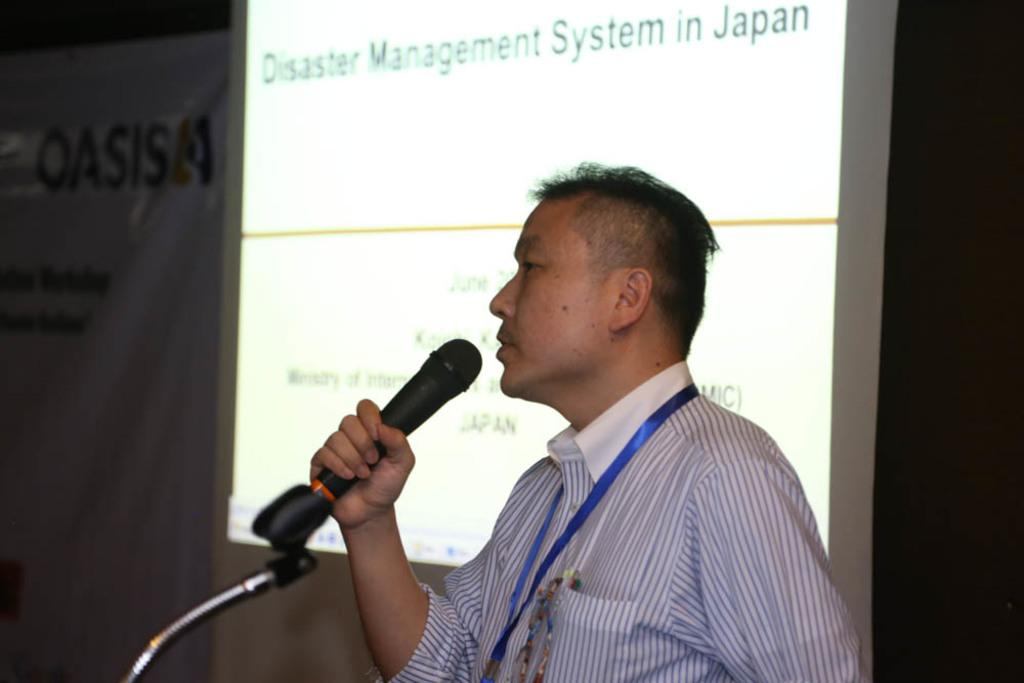Who is in the image? There is a person in the image. What is the person holding? The person is holding a microphone. What can be seen on the display in the image? The display shows the text "disaster management system in japan." What might the person be discussing or presenting based on the display content? The person might be discussing or presenting information about the disaster management system in Japan. What afterthought did the person have while holding the microphone in the image? There is no indication of an afterthought in the image, as it only shows the person holding a microphone and the projector display. 